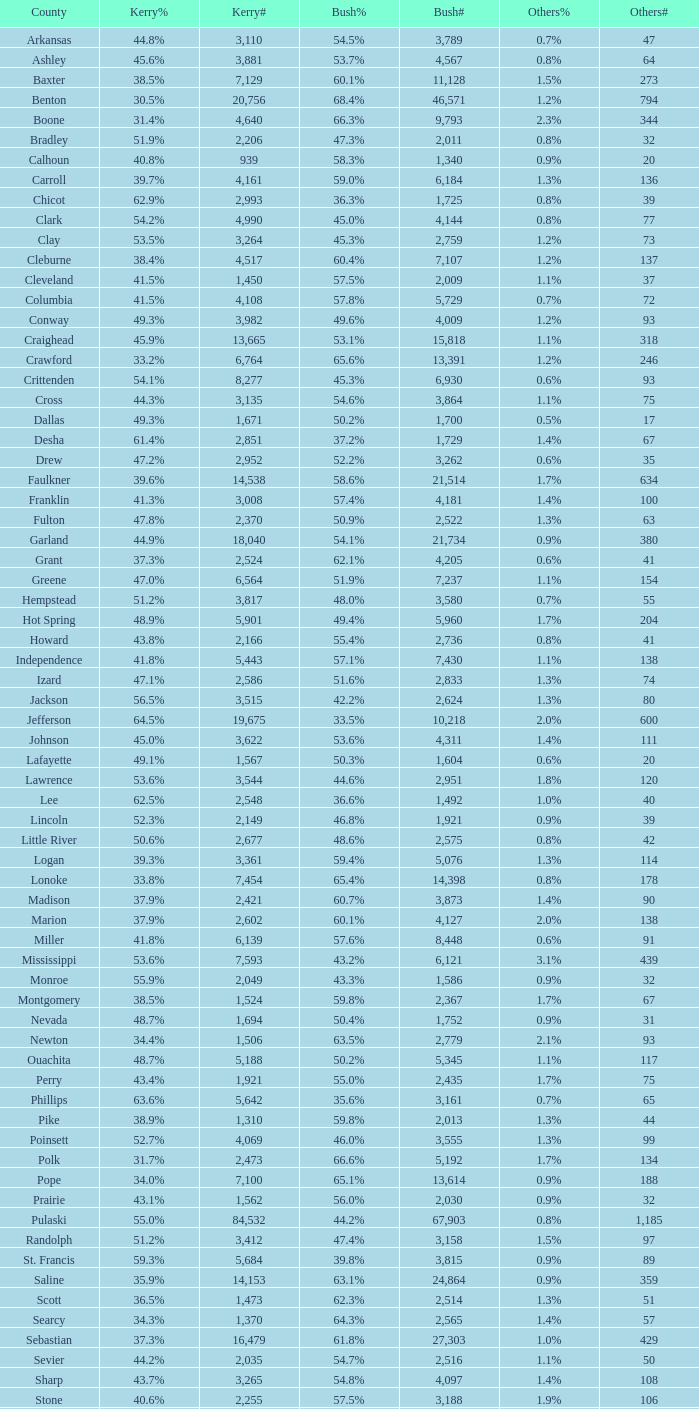What is the lowest Kerry#, when Others# is "106", and when Bush# is less than 3,188? None. 